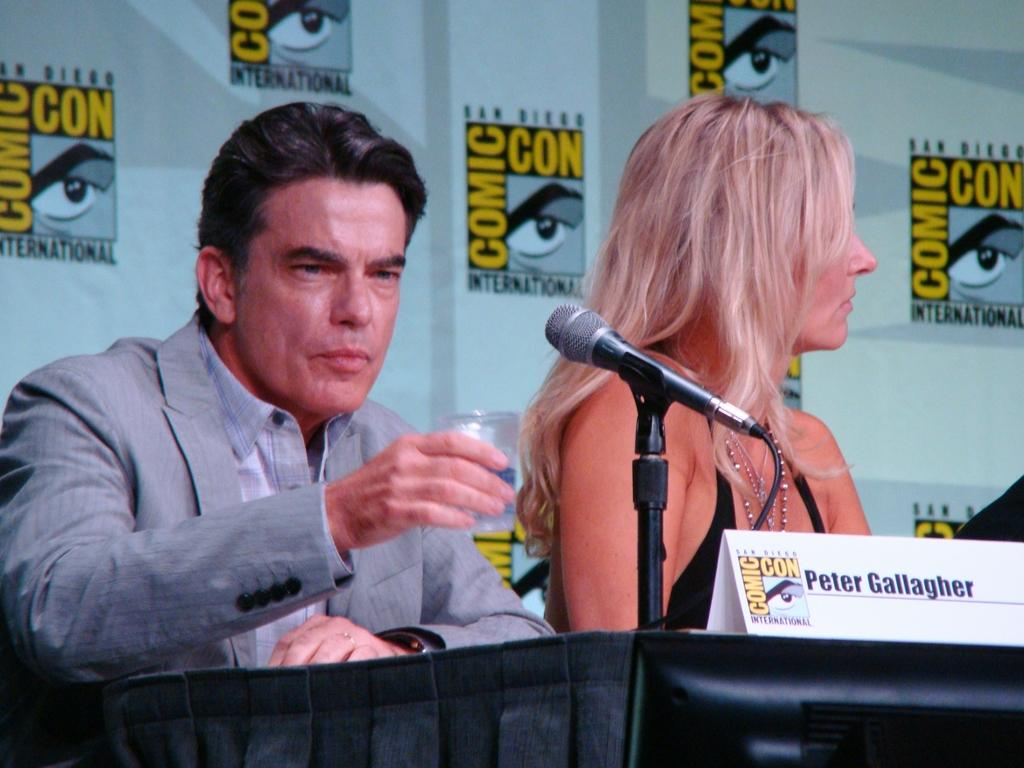Who are the people in the image? There is a man and a woman in the image. What is in front of the man and woman? There is a mic in front of the man and woman. What can be seen behind the man and woman? There are comic con posters behind the man and woman. What type of cat is sitting on the substance in the room? There is no cat or substance present in the image, and the image does not depict a room. 